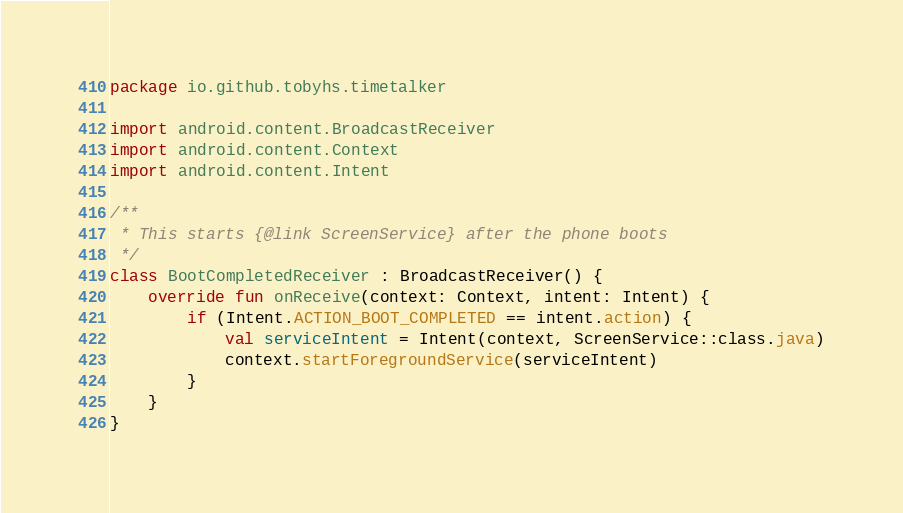Convert code to text. <code><loc_0><loc_0><loc_500><loc_500><_Kotlin_>package io.github.tobyhs.timetalker

import android.content.BroadcastReceiver
import android.content.Context
import android.content.Intent

/**
 * This starts {@link ScreenService} after the phone boots
 */
class BootCompletedReceiver : BroadcastReceiver() {
    override fun onReceive(context: Context, intent: Intent) {
        if (Intent.ACTION_BOOT_COMPLETED == intent.action) {
            val serviceIntent = Intent(context, ScreenService::class.java)
            context.startForegroundService(serviceIntent)
        }
    }
}
</code> 